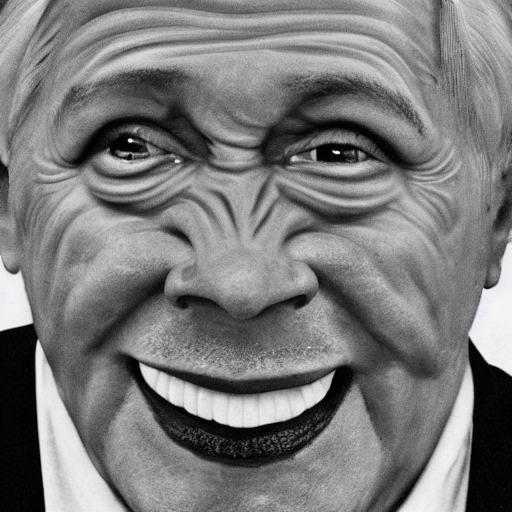Does this photograph seem staged or candid, and why? The photograph gives the impression of being carefully staged. This is suggested by the deliberate lighting, the focused composition that centers on the subject's face, and the vivid facial expression which seems to be presented for the viewer. These elements all imply a level of preparation and intention in capturing the image. 